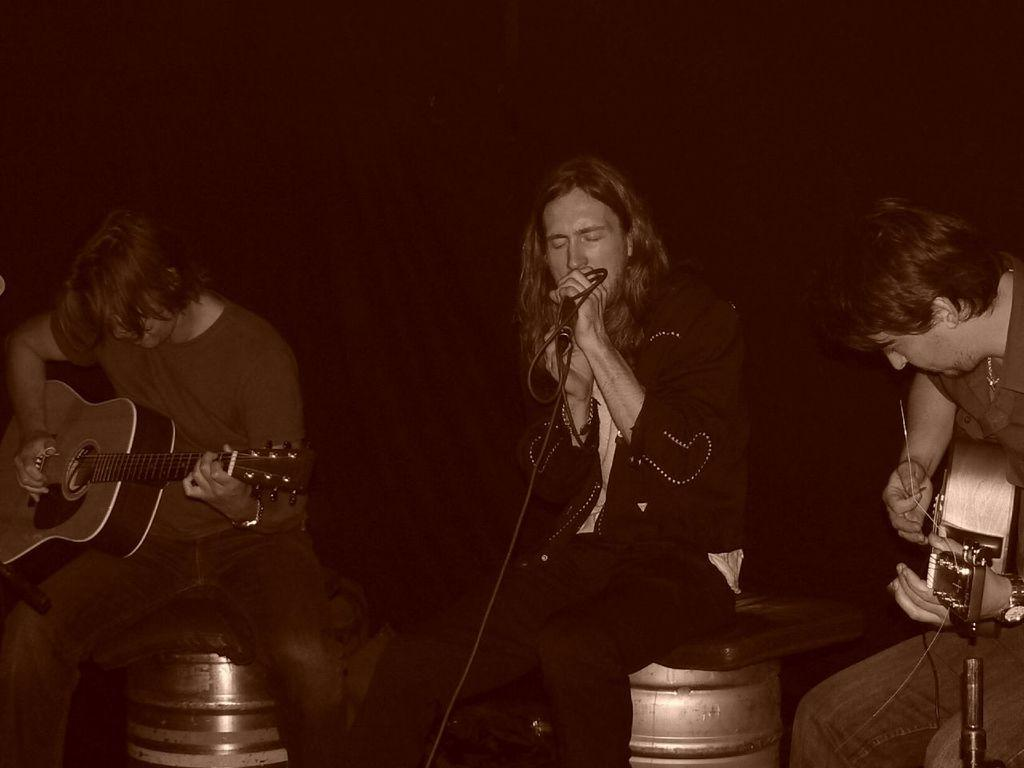How many people are in the image? There are three members in the image. What are the members doing in the image? The members are sitting on drums and playing musical instruments. What is the middle member doing specifically? The middle member is singing and holding a mic. What is the color of the background in the image? The background of the image is dark. What type of chess game is being played in the image? A: There is no chess game present in the image; it features three members playing musical instruments. What season is depicted in the image? The image does not depict a specific season, and the background is dark, making it difficult to determine the time of year. 